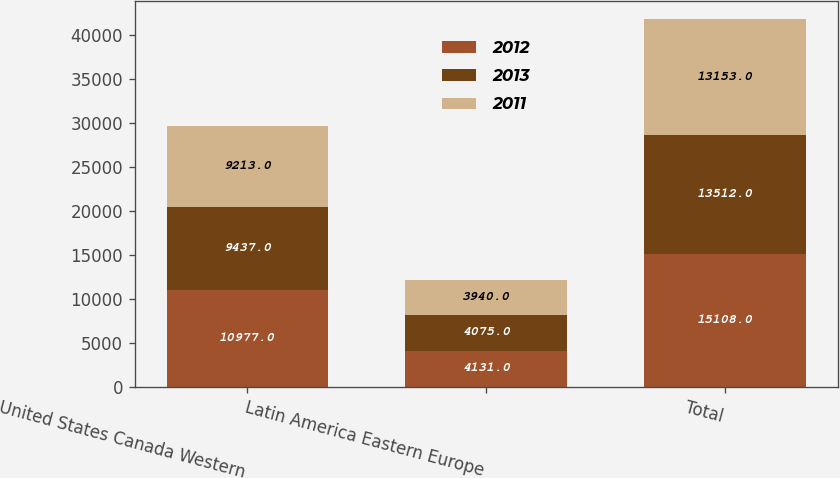<chart> <loc_0><loc_0><loc_500><loc_500><stacked_bar_chart><ecel><fcel>United States Canada Western<fcel>Latin America Eastern Europe<fcel>Total<nl><fcel>2012<fcel>10977<fcel>4131<fcel>15108<nl><fcel>2013<fcel>9437<fcel>4075<fcel>13512<nl><fcel>2011<fcel>9213<fcel>3940<fcel>13153<nl></chart> 